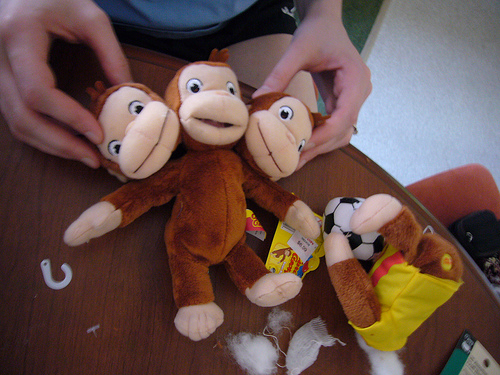<image>
Is the toy on the table? Yes. Looking at the image, I can see the toy is positioned on top of the table, with the table providing support. 